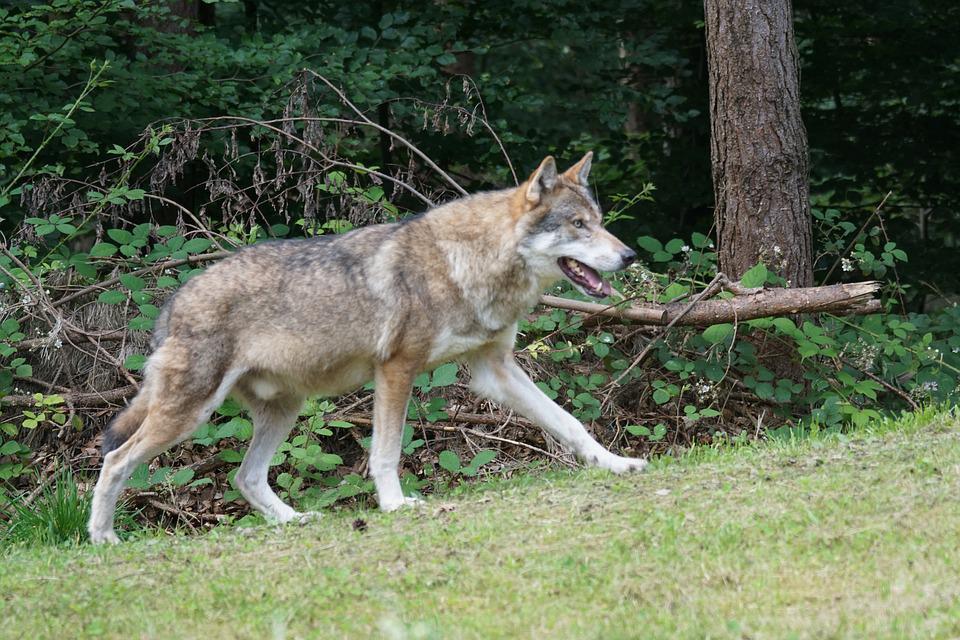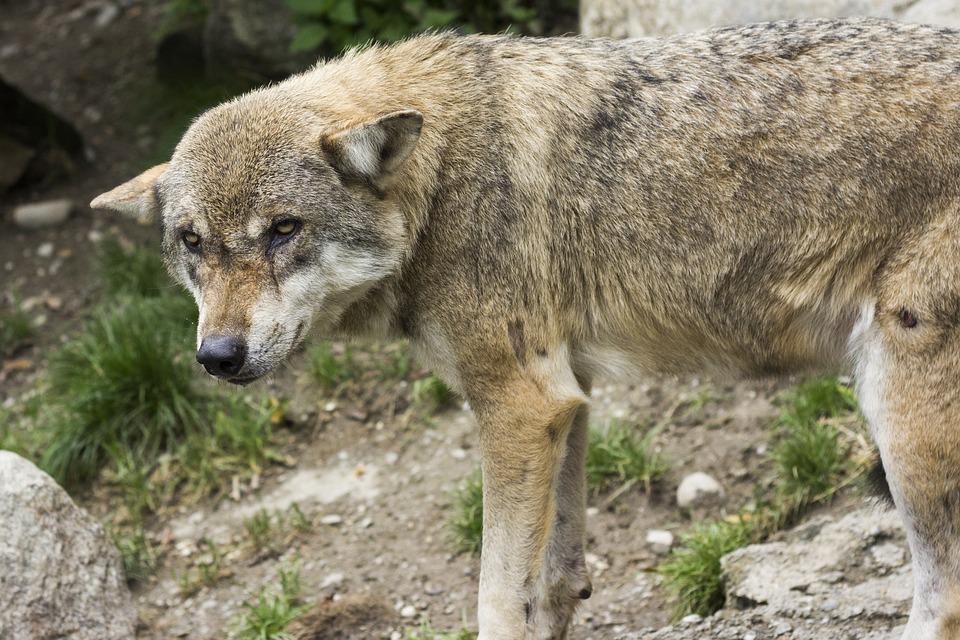The first image is the image on the left, the second image is the image on the right. For the images shown, is this caption "An image contains exactly four wolves posed similarly and side-by-side." true? Answer yes or no. No. The first image is the image on the left, the second image is the image on the right. Assess this claim about the two images: "The right image contains exactly one wolf.". Correct or not? Answer yes or no. Yes. 